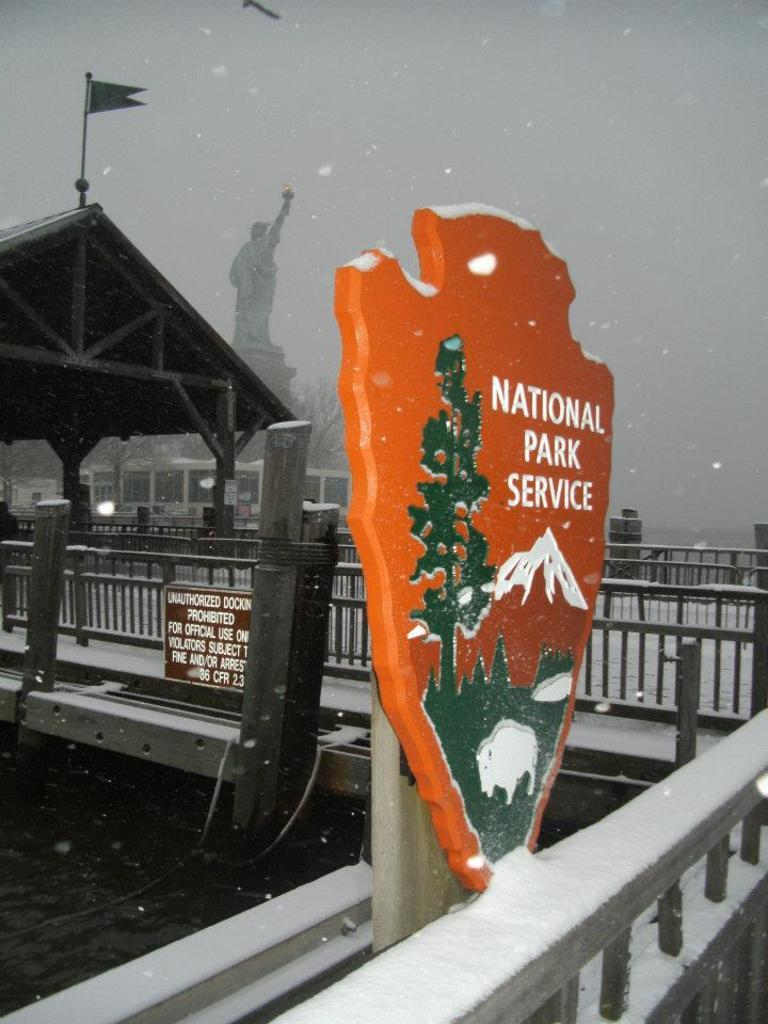What objects can be seen in the image? There are boards, a flag, a sculpture, a fence, and trees in the image. What structure is present in the image? There is a building in the image. What can be seen in the background of the image? The sky is visible in the background of the image. What type of sweater is being worn by the appliance in the image? There is no appliance or sweater present in the image. How does the flag pull the sculpture towards the fence in the image? The flag does not pull the sculpture towards the fence in the image; there is no interaction between the flag and the sculpture. 